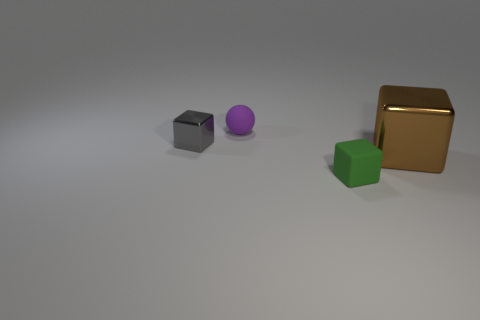Add 3 yellow matte spheres. How many objects exist? 7 Subtract all balls. How many objects are left? 3 Add 3 tiny rubber spheres. How many tiny rubber spheres are left? 4 Add 2 brown metal cylinders. How many brown metal cylinders exist? 2 Subtract 0 blue cubes. How many objects are left? 4 Subtract all small gray cubes. Subtract all small gray metallic cubes. How many objects are left? 2 